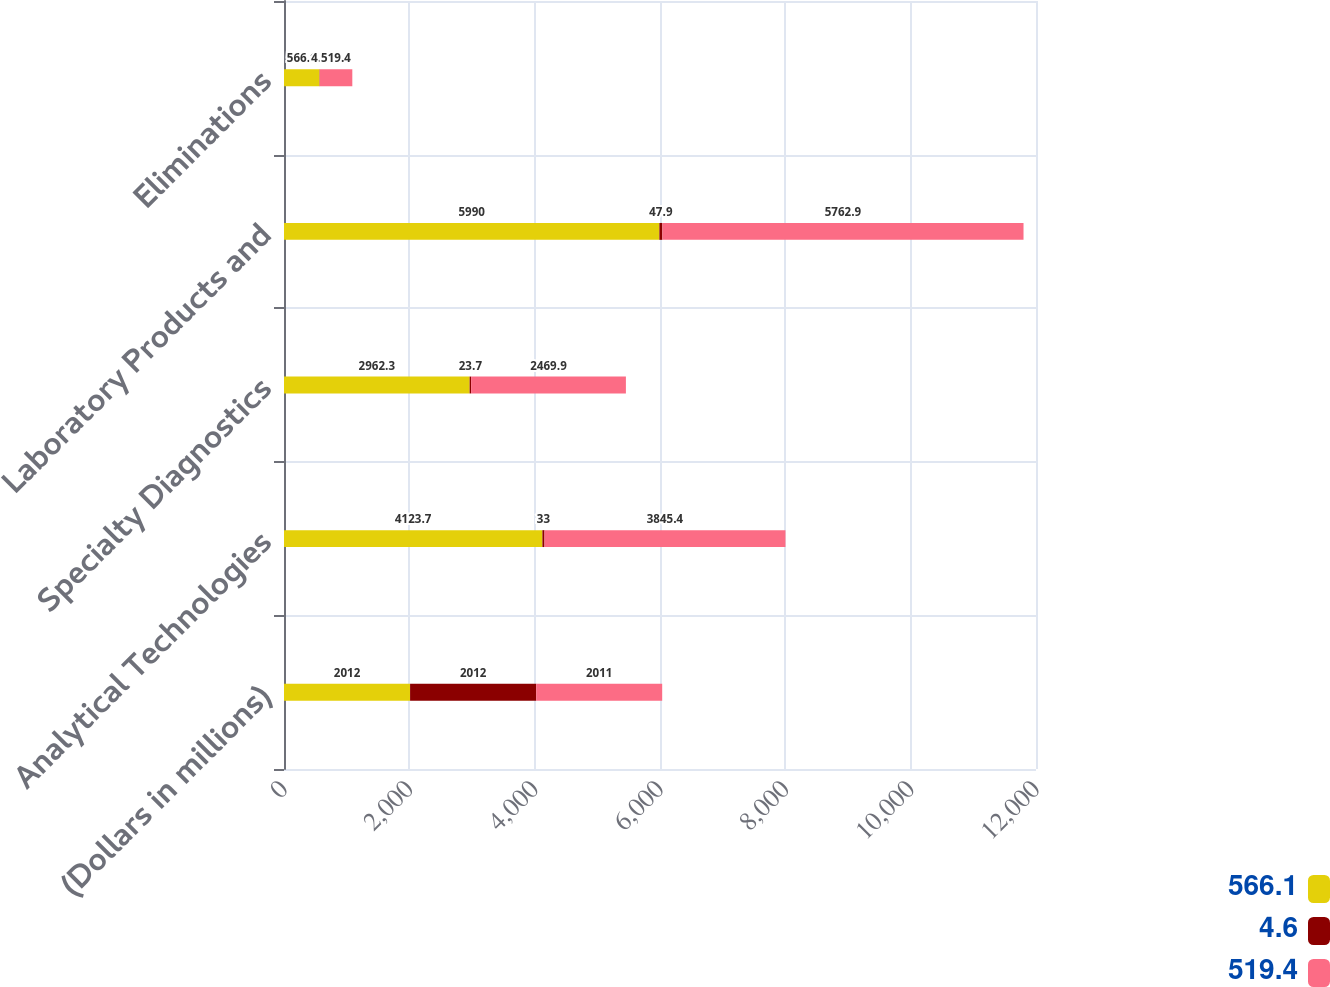Convert chart. <chart><loc_0><loc_0><loc_500><loc_500><stacked_bar_chart><ecel><fcel>(Dollars in millions)<fcel>Analytical Technologies<fcel>Specialty Diagnostics<fcel>Laboratory Products and<fcel>Eliminations<nl><fcel>566.1<fcel>2012<fcel>4123.7<fcel>2962.3<fcel>5990<fcel>566.1<nl><fcel>4.6<fcel>2012<fcel>33<fcel>23.7<fcel>47.9<fcel>4.6<nl><fcel>519.4<fcel>2011<fcel>3845.4<fcel>2469.9<fcel>5762.9<fcel>519.4<nl></chart> 